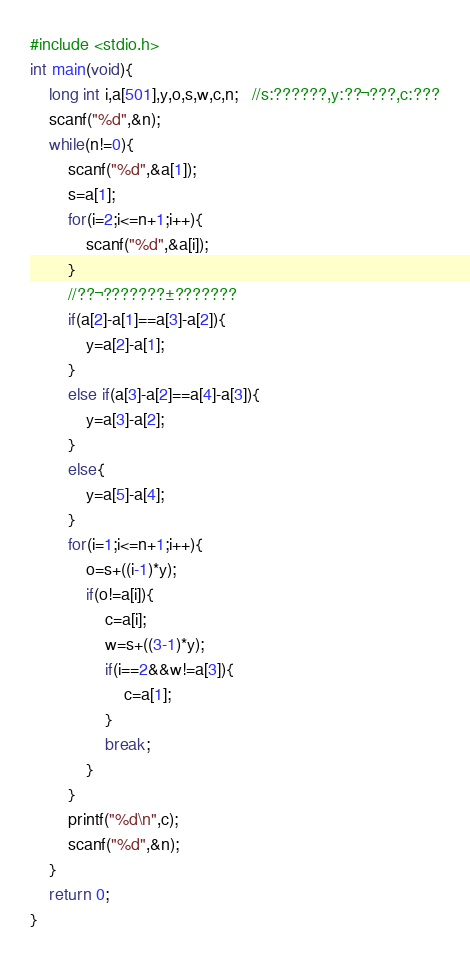<code> <loc_0><loc_0><loc_500><loc_500><_C_>#include <stdio.h>
int main(void){
	long int i,a[501],y,o,s,w,c,n;   //s:??????,y:??¬???,c:???
	scanf("%d",&n);
	while(n!=0){
		scanf("%d",&a[1]);
		s=a[1];
		for(i=2;i<=n+1;i++){
			scanf("%d",&a[i]);
		}
		//??¬???????±???????
		if(a[2]-a[1]==a[3]-a[2]){
			y=a[2]-a[1];
		}
		else if(a[3]-a[2]==a[4]-a[3]){
			y=a[3]-a[2];
		}
		else{
			y=a[5]-a[4];
		}
		for(i=1;i<=n+1;i++){
			o=s+((i-1)*y);
			if(o!=a[i]){
				c=a[i];
				w=s+((3-1)*y);
				if(i==2&&w!=a[3]){
					c=a[1];
				}
				break;
			}
		}
		printf("%d\n",c);
		scanf("%d",&n);
	}
	return 0;
}</code> 